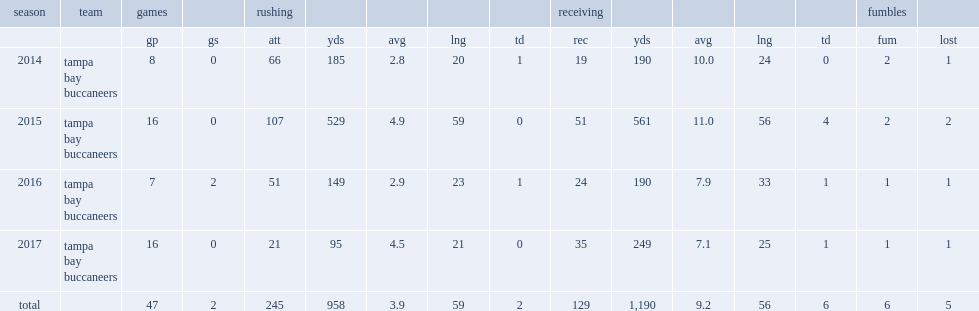How many rushing yards did charles sims get in 2014? 185.0. 